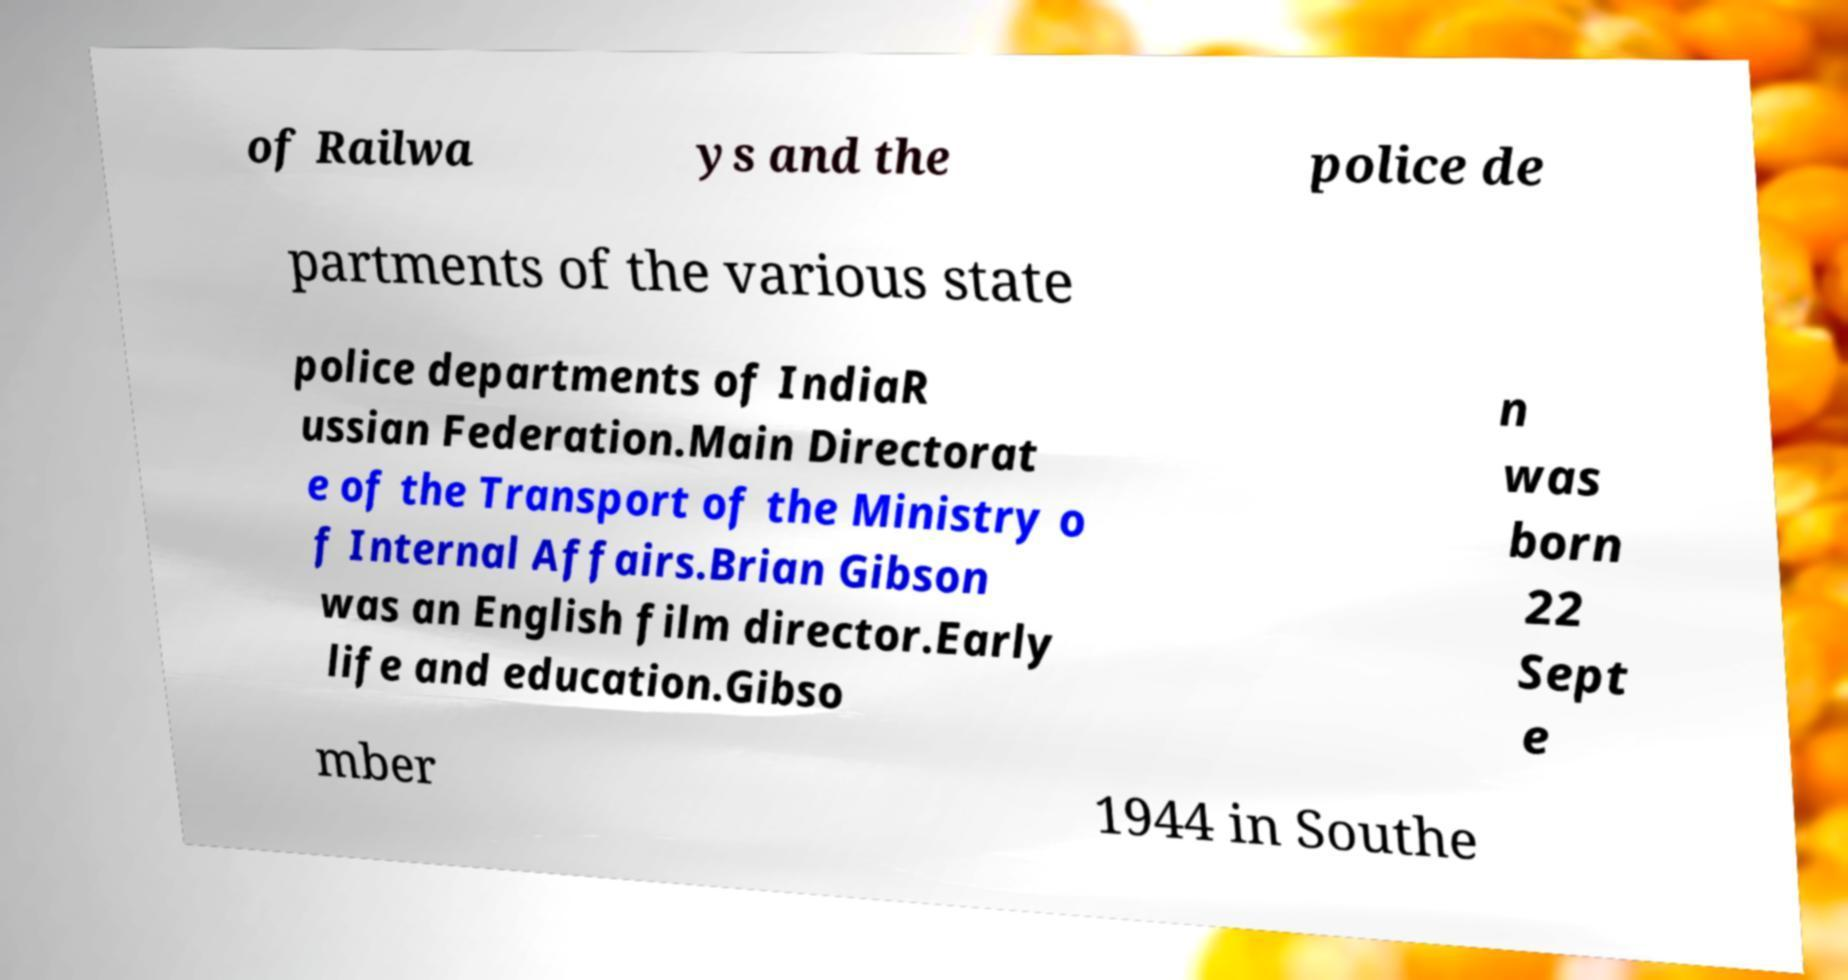Could you assist in decoding the text presented in this image and type it out clearly? of Railwa ys and the police de partments of the various state police departments of IndiaR ussian Federation.Main Directorat e of the Transport of the Ministry o f Internal Affairs.Brian Gibson was an English film director.Early life and education.Gibso n was born 22 Sept e mber 1944 in Southe 